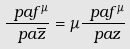Convert formula to latex. <formula><loc_0><loc_0><loc_500><loc_500>\frac { \ p a f ^ { \mu } } { \ p a \overline { z } } = \mu \frac { \ p a f ^ { \mu } } { \ p a z }</formula> 